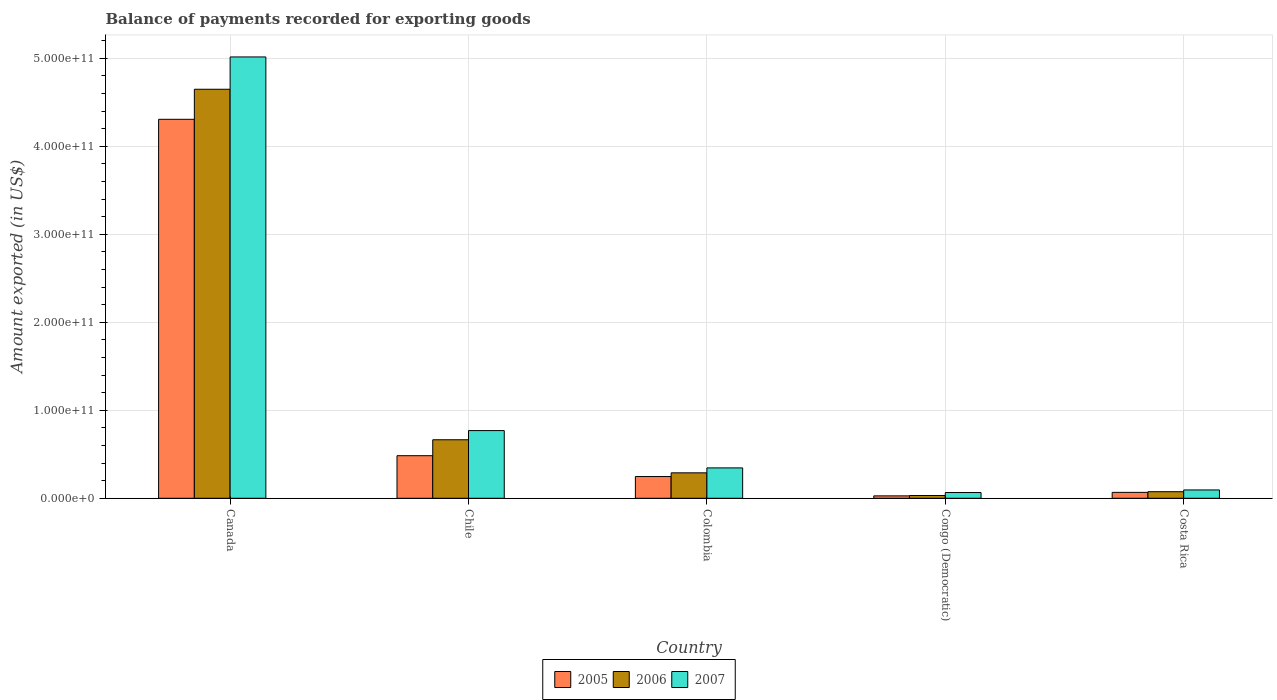How many bars are there on the 2nd tick from the left?
Offer a very short reply. 3. What is the label of the 5th group of bars from the left?
Your answer should be very brief. Costa Rica. In how many cases, is the number of bars for a given country not equal to the number of legend labels?
Your response must be concise. 0. What is the amount exported in 2005 in Congo (Democratic)?
Provide a short and direct response. 2.75e+09. Across all countries, what is the maximum amount exported in 2007?
Give a very brief answer. 5.02e+11. Across all countries, what is the minimum amount exported in 2006?
Your response must be concise. 3.14e+09. In which country was the amount exported in 2006 maximum?
Your answer should be very brief. Canada. In which country was the amount exported in 2005 minimum?
Offer a very short reply. Congo (Democratic). What is the total amount exported in 2005 in the graph?
Give a very brief answer. 5.13e+11. What is the difference between the amount exported in 2006 in Canada and that in Chile?
Make the answer very short. 3.98e+11. What is the difference between the amount exported in 2005 in Congo (Democratic) and the amount exported in 2007 in Costa Rica?
Offer a terse response. -6.73e+09. What is the average amount exported in 2007 per country?
Your answer should be compact. 1.26e+11. What is the difference between the amount exported of/in 2005 and amount exported of/in 2006 in Costa Rica?
Give a very brief answer. -7.41e+08. What is the ratio of the amount exported in 2007 in Colombia to that in Costa Rica?
Keep it short and to the point. 3.64. Is the amount exported in 2007 in Chile less than that in Colombia?
Your response must be concise. No. What is the difference between the highest and the second highest amount exported in 2005?
Your answer should be compact. 4.06e+11. What is the difference between the highest and the lowest amount exported in 2005?
Give a very brief answer. 4.28e+11. Is the sum of the amount exported in 2005 in Colombia and Costa Rica greater than the maximum amount exported in 2006 across all countries?
Make the answer very short. No. What does the 2nd bar from the left in Colombia represents?
Provide a short and direct response. 2006. How many bars are there?
Your response must be concise. 15. Are all the bars in the graph horizontal?
Ensure brevity in your answer.  No. How many countries are there in the graph?
Make the answer very short. 5. What is the difference between two consecutive major ticks on the Y-axis?
Your response must be concise. 1.00e+11. Does the graph contain any zero values?
Make the answer very short. No. Where does the legend appear in the graph?
Keep it short and to the point. Bottom center. How many legend labels are there?
Your answer should be very brief. 3. What is the title of the graph?
Provide a short and direct response. Balance of payments recorded for exporting goods. Does "1972" appear as one of the legend labels in the graph?
Offer a terse response. No. What is the label or title of the Y-axis?
Make the answer very short. Amount exported (in US$). What is the Amount exported (in US$) in 2005 in Canada?
Keep it short and to the point. 4.31e+11. What is the Amount exported (in US$) of 2006 in Canada?
Your answer should be very brief. 4.65e+11. What is the Amount exported (in US$) of 2007 in Canada?
Make the answer very short. 5.02e+11. What is the Amount exported (in US$) of 2005 in Chile?
Keep it short and to the point. 4.84e+1. What is the Amount exported (in US$) of 2006 in Chile?
Give a very brief answer. 6.65e+1. What is the Amount exported (in US$) in 2007 in Chile?
Offer a terse response. 7.69e+1. What is the Amount exported (in US$) in 2005 in Colombia?
Provide a short and direct response. 2.47e+1. What is the Amount exported (in US$) in 2006 in Colombia?
Provide a succinct answer. 2.89e+1. What is the Amount exported (in US$) of 2007 in Colombia?
Offer a terse response. 3.45e+1. What is the Amount exported (in US$) of 2005 in Congo (Democratic)?
Offer a very short reply. 2.75e+09. What is the Amount exported (in US$) in 2006 in Congo (Democratic)?
Offer a very short reply. 3.14e+09. What is the Amount exported (in US$) of 2007 in Congo (Democratic)?
Offer a terse response. 6.54e+09. What is the Amount exported (in US$) of 2005 in Costa Rica?
Give a very brief answer. 6.73e+09. What is the Amount exported (in US$) of 2006 in Costa Rica?
Your answer should be very brief. 7.47e+09. What is the Amount exported (in US$) in 2007 in Costa Rica?
Ensure brevity in your answer.  9.48e+09. Across all countries, what is the maximum Amount exported (in US$) in 2005?
Your response must be concise. 4.31e+11. Across all countries, what is the maximum Amount exported (in US$) of 2006?
Your answer should be compact. 4.65e+11. Across all countries, what is the maximum Amount exported (in US$) of 2007?
Make the answer very short. 5.02e+11. Across all countries, what is the minimum Amount exported (in US$) in 2005?
Your answer should be compact. 2.75e+09. Across all countries, what is the minimum Amount exported (in US$) in 2006?
Your response must be concise. 3.14e+09. Across all countries, what is the minimum Amount exported (in US$) of 2007?
Give a very brief answer. 6.54e+09. What is the total Amount exported (in US$) in 2005 in the graph?
Provide a short and direct response. 5.13e+11. What is the total Amount exported (in US$) of 2006 in the graph?
Offer a terse response. 5.71e+11. What is the total Amount exported (in US$) in 2007 in the graph?
Your answer should be compact. 6.29e+11. What is the difference between the Amount exported (in US$) in 2005 in Canada and that in Chile?
Your answer should be compact. 3.82e+11. What is the difference between the Amount exported (in US$) of 2006 in Canada and that in Chile?
Ensure brevity in your answer.  3.98e+11. What is the difference between the Amount exported (in US$) in 2007 in Canada and that in Chile?
Offer a terse response. 4.25e+11. What is the difference between the Amount exported (in US$) of 2005 in Canada and that in Colombia?
Your answer should be very brief. 4.06e+11. What is the difference between the Amount exported (in US$) of 2006 in Canada and that in Colombia?
Make the answer very short. 4.36e+11. What is the difference between the Amount exported (in US$) in 2007 in Canada and that in Colombia?
Your response must be concise. 4.67e+11. What is the difference between the Amount exported (in US$) of 2005 in Canada and that in Congo (Democratic)?
Your answer should be compact. 4.28e+11. What is the difference between the Amount exported (in US$) of 2006 in Canada and that in Congo (Democratic)?
Ensure brevity in your answer.  4.62e+11. What is the difference between the Amount exported (in US$) in 2007 in Canada and that in Congo (Democratic)?
Your response must be concise. 4.95e+11. What is the difference between the Amount exported (in US$) of 2005 in Canada and that in Costa Rica?
Make the answer very short. 4.24e+11. What is the difference between the Amount exported (in US$) in 2006 in Canada and that in Costa Rica?
Provide a succinct answer. 4.57e+11. What is the difference between the Amount exported (in US$) of 2007 in Canada and that in Costa Rica?
Provide a succinct answer. 4.92e+11. What is the difference between the Amount exported (in US$) in 2005 in Chile and that in Colombia?
Offer a terse response. 2.37e+1. What is the difference between the Amount exported (in US$) in 2006 in Chile and that in Colombia?
Give a very brief answer. 3.76e+1. What is the difference between the Amount exported (in US$) of 2007 in Chile and that in Colombia?
Your response must be concise. 4.24e+1. What is the difference between the Amount exported (in US$) of 2005 in Chile and that in Congo (Democratic)?
Keep it short and to the point. 4.57e+1. What is the difference between the Amount exported (in US$) in 2006 in Chile and that in Congo (Democratic)?
Provide a short and direct response. 6.34e+1. What is the difference between the Amount exported (in US$) in 2007 in Chile and that in Congo (Democratic)?
Your response must be concise. 7.04e+1. What is the difference between the Amount exported (in US$) in 2005 in Chile and that in Costa Rica?
Provide a succinct answer. 4.17e+1. What is the difference between the Amount exported (in US$) in 2006 in Chile and that in Costa Rica?
Offer a terse response. 5.90e+1. What is the difference between the Amount exported (in US$) of 2007 in Chile and that in Costa Rica?
Your answer should be compact. 6.75e+1. What is the difference between the Amount exported (in US$) of 2005 in Colombia and that in Congo (Democratic)?
Ensure brevity in your answer.  2.20e+1. What is the difference between the Amount exported (in US$) of 2006 in Colombia and that in Congo (Democratic)?
Provide a short and direct response. 2.58e+1. What is the difference between the Amount exported (in US$) of 2007 in Colombia and that in Congo (Democratic)?
Offer a very short reply. 2.80e+1. What is the difference between the Amount exported (in US$) of 2005 in Colombia and that in Costa Rica?
Offer a terse response. 1.80e+1. What is the difference between the Amount exported (in US$) in 2006 in Colombia and that in Costa Rica?
Your answer should be compact. 2.14e+1. What is the difference between the Amount exported (in US$) of 2007 in Colombia and that in Costa Rica?
Your answer should be compact. 2.51e+1. What is the difference between the Amount exported (in US$) in 2005 in Congo (Democratic) and that in Costa Rica?
Keep it short and to the point. -3.98e+09. What is the difference between the Amount exported (in US$) in 2006 in Congo (Democratic) and that in Costa Rica?
Your response must be concise. -4.33e+09. What is the difference between the Amount exported (in US$) in 2007 in Congo (Democratic) and that in Costa Rica?
Ensure brevity in your answer.  -2.94e+09. What is the difference between the Amount exported (in US$) in 2005 in Canada and the Amount exported (in US$) in 2006 in Chile?
Provide a succinct answer. 3.64e+11. What is the difference between the Amount exported (in US$) of 2005 in Canada and the Amount exported (in US$) of 2007 in Chile?
Keep it short and to the point. 3.54e+11. What is the difference between the Amount exported (in US$) of 2006 in Canada and the Amount exported (in US$) of 2007 in Chile?
Give a very brief answer. 3.88e+11. What is the difference between the Amount exported (in US$) of 2005 in Canada and the Amount exported (in US$) of 2006 in Colombia?
Offer a very short reply. 4.02e+11. What is the difference between the Amount exported (in US$) in 2005 in Canada and the Amount exported (in US$) in 2007 in Colombia?
Your answer should be very brief. 3.96e+11. What is the difference between the Amount exported (in US$) of 2006 in Canada and the Amount exported (in US$) of 2007 in Colombia?
Your answer should be compact. 4.30e+11. What is the difference between the Amount exported (in US$) in 2005 in Canada and the Amount exported (in US$) in 2006 in Congo (Democratic)?
Offer a very short reply. 4.28e+11. What is the difference between the Amount exported (in US$) of 2005 in Canada and the Amount exported (in US$) of 2007 in Congo (Democratic)?
Ensure brevity in your answer.  4.24e+11. What is the difference between the Amount exported (in US$) in 2006 in Canada and the Amount exported (in US$) in 2007 in Congo (Democratic)?
Your response must be concise. 4.58e+11. What is the difference between the Amount exported (in US$) in 2005 in Canada and the Amount exported (in US$) in 2006 in Costa Rica?
Your response must be concise. 4.23e+11. What is the difference between the Amount exported (in US$) in 2005 in Canada and the Amount exported (in US$) in 2007 in Costa Rica?
Provide a short and direct response. 4.21e+11. What is the difference between the Amount exported (in US$) in 2006 in Canada and the Amount exported (in US$) in 2007 in Costa Rica?
Make the answer very short. 4.55e+11. What is the difference between the Amount exported (in US$) of 2005 in Chile and the Amount exported (in US$) of 2006 in Colombia?
Your answer should be very brief. 1.95e+1. What is the difference between the Amount exported (in US$) of 2005 in Chile and the Amount exported (in US$) of 2007 in Colombia?
Your answer should be very brief. 1.39e+1. What is the difference between the Amount exported (in US$) of 2006 in Chile and the Amount exported (in US$) of 2007 in Colombia?
Keep it short and to the point. 3.20e+1. What is the difference between the Amount exported (in US$) of 2005 in Chile and the Amount exported (in US$) of 2006 in Congo (Democratic)?
Provide a succinct answer. 4.53e+1. What is the difference between the Amount exported (in US$) of 2005 in Chile and the Amount exported (in US$) of 2007 in Congo (Democratic)?
Provide a succinct answer. 4.19e+1. What is the difference between the Amount exported (in US$) in 2006 in Chile and the Amount exported (in US$) in 2007 in Congo (Democratic)?
Provide a succinct answer. 6.00e+1. What is the difference between the Amount exported (in US$) in 2005 in Chile and the Amount exported (in US$) in 2006 in Costa Rica?
Offer a very short reply. 4.09e+1. What is the difference between the Amount exported (in US$) in 2005 in Chile and the Amount exported (in US$) in 2007 in Costa Rica?
Keep it short and to the point. 3.89e+1. What is the difference between the Amount exported (in US$) in 2006 in Chile and the Amount exported (in US$) in 2007 in Costa Rica?
Provide a succinct answer. 5.70e+1. What is the difference between the Amount exported (in US$) in 2005 in Colombia and the Amount exported (in US$) in 2006 in Congo (Democratic)?
Give a very brief answer. 2.16e+1. What is the difference between the Amount exported (in US$) in 2005 in Colombia and the Amount exported (in US$) in 2007 in Congo (Democratic)?
Your response must be concise. 1.82e+1. What is the difference between the Amount exported (in US$) in 2006 in Colombia and the Amount exported (in US$) in 2007 in Congo (Democratic)?
Your answer should be very brief. 2.24e+1. What is the difference between the Amount exported (in US$) of 2005 in Colombia and the Amount exported (in US$) of 2006 in Costa Rica?
Keep it short and to the point. 1.72e+1. What is the difference between the Amount exported (in US$) of 2005 in Colombia and the Amount exported (in US$) of 2007 in Costa Rica?
Offer a very short reply. 1.52e+1. What is the difference between the Amount exported (in US$) of 2006 in Colombia and the Amount exported (in US$) of 2007 in Costa Rica?
Keep it short and to the point. 1.94e+1. What is the difference between the Amount exported (in US$) of 2005 in Congo (Democratic) and the Amount exported (in US$) of 2006 in Costa Rica?
Your response must be concise. -4.72e+09. What is the difference between the Amount exported (in US$) of 2005 in Congo (Democratic) and the Amount exported (in US$) of 2007 in Costa Rica?
Make the answer very short. -6.73e+09. What is the difference between the Amount exported (in US$) of 2006 in Congo (Democratic) and the Amount exported (in US$) of 2007 in Costa Rica?
Keep it short and to the point. -6.34e+09. What is the average Amount exported (in US$) in 2005 per country?
Your answer should be very brief. 1.03e+11. What is the average Amount exported (in US$) of 2006 per country?
Make the answer very short. 1.14e+11. What is the average Amount exported (in US$) in 2007 per country?
Your answer should be compact. 1.26e+11. What is the difference between the Amount exported (in US$) of 2005 and Amount exported (in US$) of 2006 in Canada?
Make the answer very short. -3.41e+1. What is the difference between the Amount exported (in US$) in 2005 and Amount exported (in US$) in 2007 in Canada?
Make the answer very short. -7.09e+1. What is the difference between the Amount exported (in US$) in 2006 and Amount exported (in US$) in 2007 in Canada?
Make the answer very short. -3.67e+1. What is the difference between the Amount exported (in US$) of 2005 and Amount exported (in US$) of 2006 in Chile?
Ensure brevity in your answer.  -1.81e+1. What is the difference between the Amount exported (in US$) of 2005 and Amount exported (in US$) of 2007 in Chile?
Provide a short and direct response. -2.85e+1. What is the difference between the Amount exported (in US$) in 2006 and Amount exported (in US$) in 2007 in Chile?
Give a very brief answer. -1.04e+1. What is the difference between the Amount exported (in US$) of 2005 and Amount exported (in US$) of 2006 in Colombia?
Give a very brief answer. -4.21e+09. What is the difference between the Amount exported (in US$) in 2005 and Amount exported (in US$) in 2007 in Colombia?
Offer a terse response. -9.83e+09. What is the difference between the Amount exported (in US$) in 2006 and Amount exported (in US$) in 2007 in Colombia?
Keep it short and to the point. -5.61e+09. What is the difference between the Amount exported (in US$) in 2005 and Amount exported (in US$) in 2006 in Congo (Democratic)?
Your answer should be compact. -3.92e+08. What is the difference between the Amount exported (in US$) of 2005 and Amount exported (in US$) of 2007 in Congo (Democratic)?
Offer a very short reply. -3.79e+09. What is the difference between the Amount exported (in US$) in 2006 and Amount exported (in US$) in 2007 in Congo (Democratic)?
Your answer should be very brief. -3.40e+09. What is the difference between the Amount exported (in US$) in 2005 and Amount exported (in US$) in 2006 in Costa Rica?
Your response must be concise. -7.41e+08. What is the difference between the Amount exported (in US$) in 2005 and Amount exported (in US$) in 2007 in Costa Rica?
Provide a succinct answer. -2.75e+09. What is the difference between the Amount exported (in US$) in 2006 and Amount exported (in US$) in 2007 in Costa Rica?
Keep it short and to the point. -2.01e+09. What is the ratio of the Amount exported (in US$) in 2005 in Canada to that in Chile?
Give a very brief answer. 8.9. What is the ratio of the Amount exported (in US$) in 2006 in Canada to that in Chile?
Give a very brief answer. 6.99. What is the ratio of the Amount exported (in US$) of 2007 in Canada to that in Chile?
Your answer should be compact. 6.52. What is the ratio of the Amount exported (in US$) in 2005 in Canada to that in Colombia?
Keep it short and to the point. 17.44. What is the ratio of the Amount exported (in US$) in 2006 in Canada to that in Colombia?
Give a very brief answer. 16.08. What is the ratio of the Amount exported (in US$) of 2007 in Canada to that in Colombia?
Provide a short and direct response. 14.53. What is the ratio of the Amount exported (in US$) of 2005 in Canada to that in Congo (Democratic)?
Offer a very short reply. 156.86. What is the ratio of the Amount exported (in US$) in 2006 in Canada to that in Congo (Democratic)?
Provide a short and direct response. 148.16. What is the ratio of the Amount exported (in US$) of 2007 in Canada to that in Congo (Democratic)?
Your answer should be very brief. 76.7. What is the ratio of the Amount exported (in US$) in 2005 in Canada to that in Costa Rica?
Your answer should be very brief. 64.02. What is the ratio of the Amount exported (in US$) in 2006 in Canada to that in Costa Rica?
Provide a short and direct response. 62.24. What is the ratio of the Amount exported (in US$) in 2007 in Canada to that in Costa Rica?
Make the answer very short. 52.93. What is the ratio of the Amount exported (in US$) in 2005 in Chile to that in Colombia?
Make the answer very short. 1.96. What is the ratio of the Amount exported (in US$) of 2006 in Chile to that in Colombia?
Provide a succinct answer. 2.3. What is the ratio of the Amount exported (in US$) of 2007 in Chile to that in Colombia?
Keep it short and to the point. 2.23. What is the ratio of the Amount exported (in US$) in 2005 in Chile to that in Congo (Democratic)?
Make the answer very short. 17.63. What is the ratio of the Amount exported (in US$) in 2006 in Chile to that in Congo (Democratic)?
Give a very brief answer. 21.2. What is the ratio of the Amount exported (in US$) of 2007 in Chile to that in Congo (Democratic)?
Your response must be concise. 11.76. What is the ratio of the Amount exported (in US$) in 2005 in Chile to that in Costa Rica?
Keep it short and to the point. 7.19. What is the ratio of the Amount exported (in US$) of 2006 in Chile to that in Costa Rica?
Offer a very short reply. 8.9. What is the ratio of the Amount exported (in US$) in 2007 in Chile to that in Costa Rica?
Your answer should be very brief. 8.12. What is the ratio of the Amount exported (in US$) in 2005 in Colombia to that in Congo (Democratic)?
Ensure brevity in your answer.  9. What is the ratio of the Amount exported (in US$) of 2006 in Colombia to that in Congo (Democratic)?
Your answer should be very brief. 9.22. What is the ratio of the Amount exported (in US$) of 2007 in Colombia to that in Congo (Democratic)?
Provide a succinct answer. 5.28. What is the ratio of the Amount exported (in US$) in 2005 in Colombia to that in Costa Rica?
Keep it short and to the point. 3.67. What is the ratio of the Amount exported (in US$) in 2006 in Colombia to that in Costa Rica?
Keep it short and to the point. 3.87. What is the ratio of the Amount exported (in US$) of 2007 in Colombia to that in Costa Rica?
Provide a short and direct response. 3.64. What is the ratio of the Amount exported (in US$) of 2005 in Congo (Democratic) to that in Costa Rica?
Provide a succinct answer. 0.41. What is the ratio of the Amount exported (in US$) of 2006 in Congo (Democratic) to that in Costa Rica?
Provide a succinct answer. 0.42. What is the ratio of the Amount exported (in US$) of 2007 in Congo (Democratic) to that in Costa Rica?
Your response must be concise. 0.69. What is the difference between the highest and the second highest Amount exported (in US$) in 2005?
Give a very brief answer. 3.82e+11. What is the difference between the highest and the second highest Amount exported (in US$) in 2006?
Provide a short and direct response. 3.98e+11. What is the difference between the highest and the second highest Amount exported (in US$) in 2007?
Offer a terse response. 4.25e+11. What is the difference between the highest and the lowest Amount exported (in US$) in 2005?
Provide a succinct answer. 4.28e+11. What is the difference between the highest and the lowest Amount exported (in US$) in 2006?
Provide a succinct answer. 4.62e+11. What is the difference between the highest and the lowest Amount exported (in US$) of 2007?
Make the answer very short. 4.95e+11. 